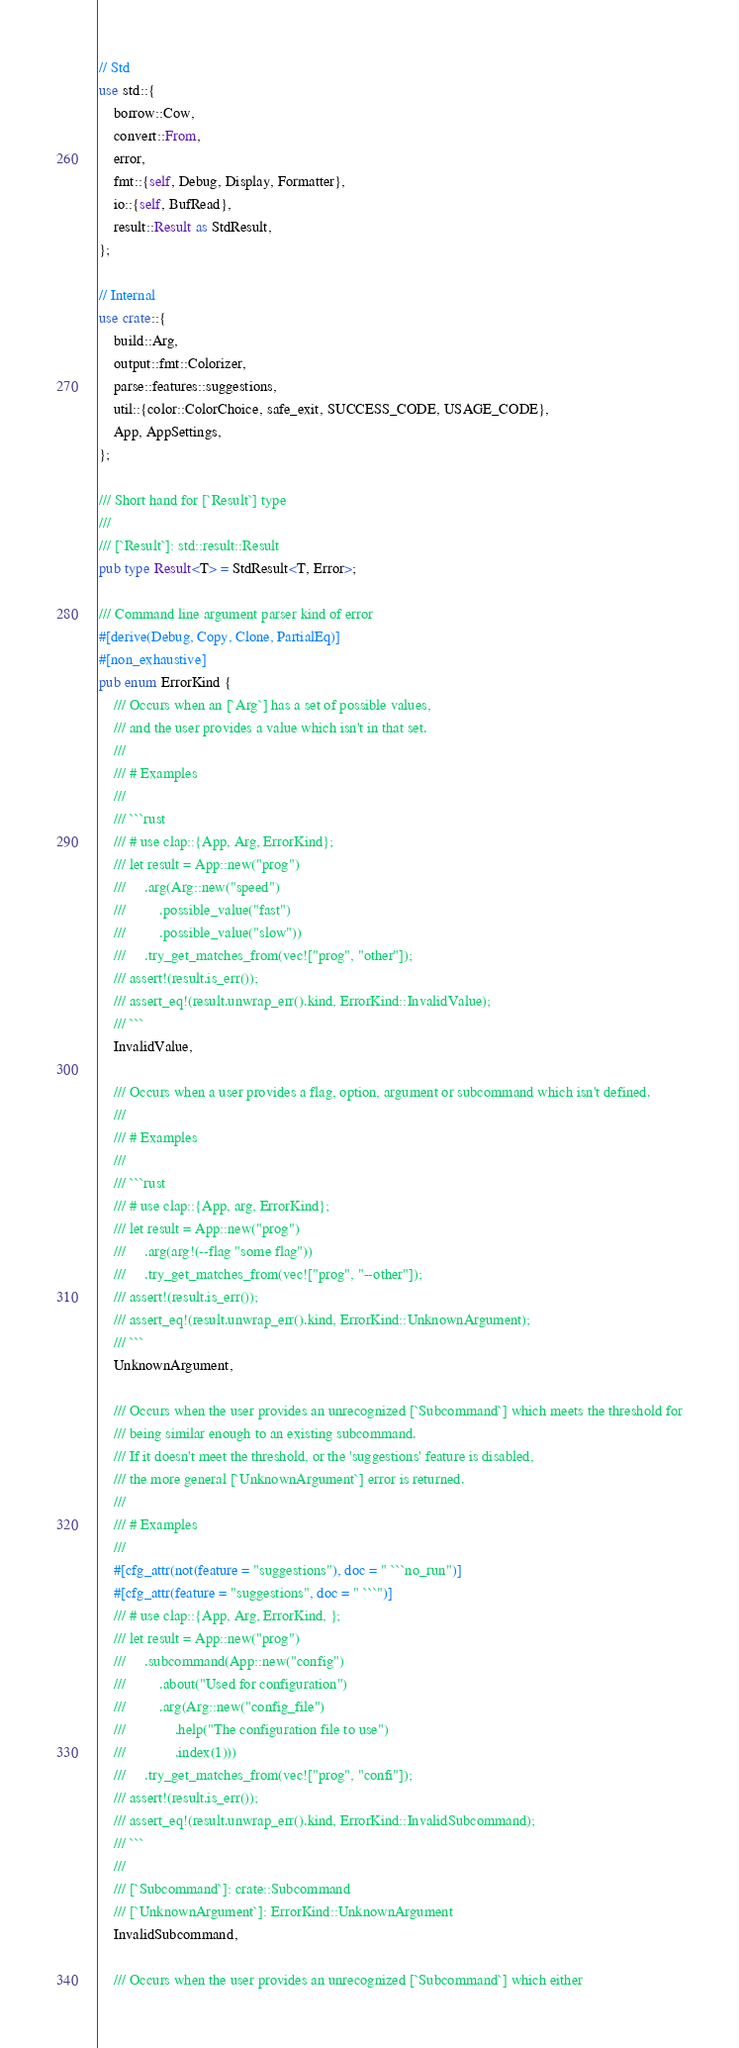Convert code to text. <code><loc_0><loc_0><loc_500><loc_500><_Rust_>// Std
use std::{
    borrow::Cow,
    convert::From,
    error,
    fmt::{self, Debug, Display, Formatter},
    io::{self, BufRead},
    result::Result as StdResult,
};

// Internal
use crate::{
    build::Arg,
    output::fmt::Colorizer,
    parse::features::suggestions,
    util::{color::ColorChoice, safe_exit, SUCCESS_CODE, USAGE_CODE},
    App, AppSettings,
};

/// Short hand for [`Result`] type
///
/// [`Result`]: std::result::Result
pub type Result<T> = StdResult<T, Error>;

/// Command line argument parser kind of error
#[derive(Debug, Copy, Clone, PartialEq)]
#[non_exhaustive]
pub enum ErrorKind {
    /// Occurs when an [`Arg`] has a set of possible values,
    /// and the user provides a value which isn't in that set.
    ///
    /// # Examples
    ///
    /// ```rust
    /// # use clap::{App, Arg, ErrorKind};
    /// let result = App::new("prog")
    ///     .arg(Arg::new("speed")
    ///         .possible_value("fast")
    ///         .possible_value("slow"))
    ///     .try_get_matches_from(vec!["prog", "other"]);
    /// assert!(result.is_err());
    /// assert_eq!(result.unwrap_err().kind, ErrorKind::InvalidValue);
    /// ```
    InvalidValue,

    /// Occurs when a user provides a flag, option, argument or subcommand which isn't defined.
    ///
    /// # Examples
    ///
    /// ```rust
    /// # use clap::{App, arg, ErrorKind};
    /// let result = App::new("prog")
    ///     .arg(arg!(--flag "some flag"))
    ///     .try_get_matches_from(vec!["prog", "--other"]);
    /// assert!(result.is_err());
    /// assert_eq!(result.unwrap_err().kind, ErrorKind::UnknownArgument);
    /// ```
    UnknownArgument,

    /// Occurs when the user provides an unrecognized [`Subcommand`] which meets the threshold for
    /// being similar enough to an existing subcommand.
    /// If it doesn't meet the threshold, or the 'suggestions' feature is disabled,
    /// the more general [`UnknownArgument`] error is returned.
    ///
    /// # Examples
    ///
    #[cfg_attr(not(feature = "suggestions"), doc = " ```no_run")]
    #[cfg_attr(feature = "suggestions", doc = " ```")]
    /// # use clap::{App, Arg, ErrorKind, };
    /// let result = App::new("prog")
    ///     .subcommand(App::new("config")
    ///         .about("Used for configuration")
    ///         .arg(Arg::new("config_file")
    ///             .help("The configuration file to use")
    ///             .index(1)))
    ///     .try_get_matches_from(vec!["prog", "confi"]);
    /// assert!(result.is_err());
    /// assert_eq!(result.unwrap_err().kind, ErrorKind::InvalidSubcommand);
    /// ```
    ///
    /// [`Subcommand`]: crate::Subcommand
    /// [`UnknownArgument`]: ErrorKind::UnknownArgument
    InvalidSubcommand,

    /// Occurs when the user provides an unrecognized [`Subcommand`] which either</code> 